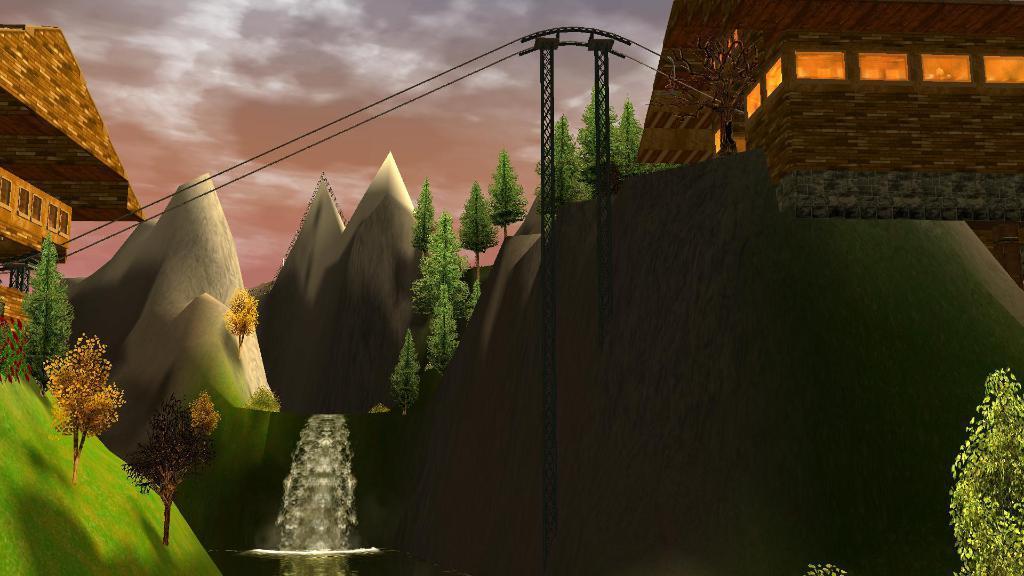In one or two sentences, can you explain what this image depicts? This is an animated picture. There is a waterfall from the hills having few trees on it. There are two poles connected with wires. Left side there is a hill having trees and a house on it. Right side there is a buildings. Right bottom there is a tree. Top of image there is sky. 